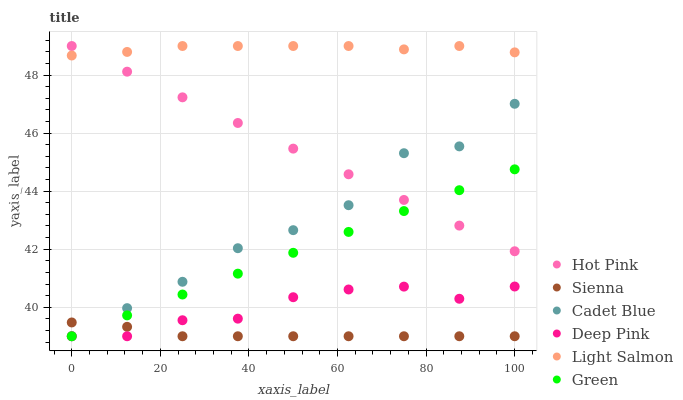Does Sienna have the minimum area under the curve?
Answer yes or no. Yes. Does Light Salmon have the maximum area under the curve?
Answer yes or no. Yes. Does Cadet Blue have the minimum area under the curve?
Answer yes or no. No. Does Cadet Blue have the maximum area under the curve?
Answer yes or no. No. Is Green the smoothest?
Answer yes or no. Yes. Is Cadet Blue the roughest?
Answer yes or no. Yes. Is Hot Pink the smoothest?
Answer yes or no. No. Is Hot Pink the roughest?
Answer yes or no. No. Does Cadet Blue have the lowest value?
Answer yes or no. Yes. Does Hot Pink have the lowest value?
Answer yes or no. No. Does Hot Pink have the highest value?
Answer yes or no. Yes. Does Cadet Blue have the highest value?
Answer yes or no. No. Is Sienna less than Hot Pink?
Answer yes or no. Yes. Is Light Salmon greater than Sienna?
Answer yes or no. Yes. Does Green intersect Deep Pink?
Answer yes or no. Yes. Is Green less than Deep Pink?
Answer yes or no. No. Is Green greater than Deep Pink?
Answer yes or no. No. Does Sienna intersect Hot Pink?
Answer yes or no. No. 